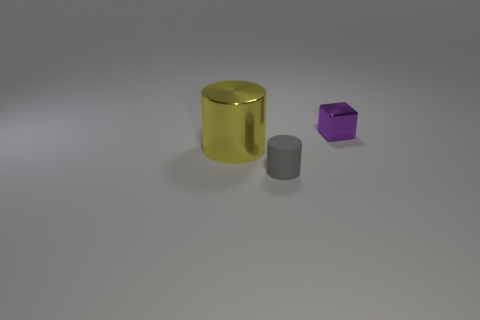Is the tiny block made of the same material as the yellow cylinder? While both the tiny block and the yellow cylinder exhibit reflective surfaces suggesting they might be made of similar materials, such as a type of smooth plastic or polished metal, the exact material cannot be determined with certainty without further tactile or compositional information. 